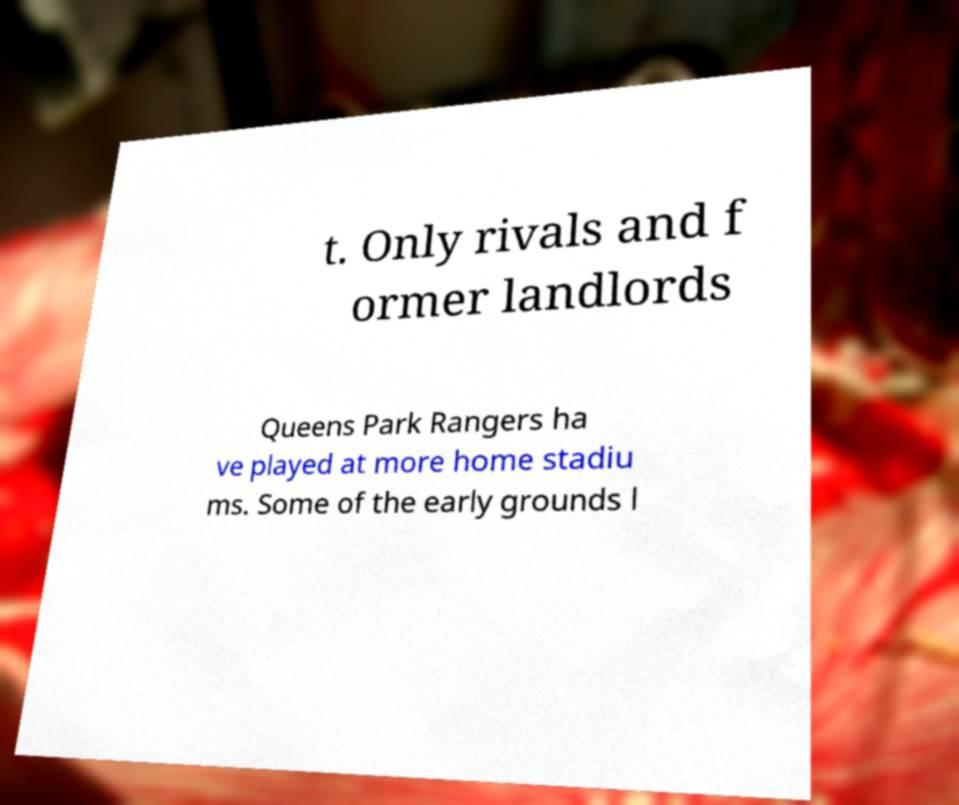There's text embedded in this image that I need extracted. Can you transcribe it verbatim? t. Only rivals and f ormer landlords Queens Park Rangers ha ve played at more home stadiu ms. Some of the early grounds l 